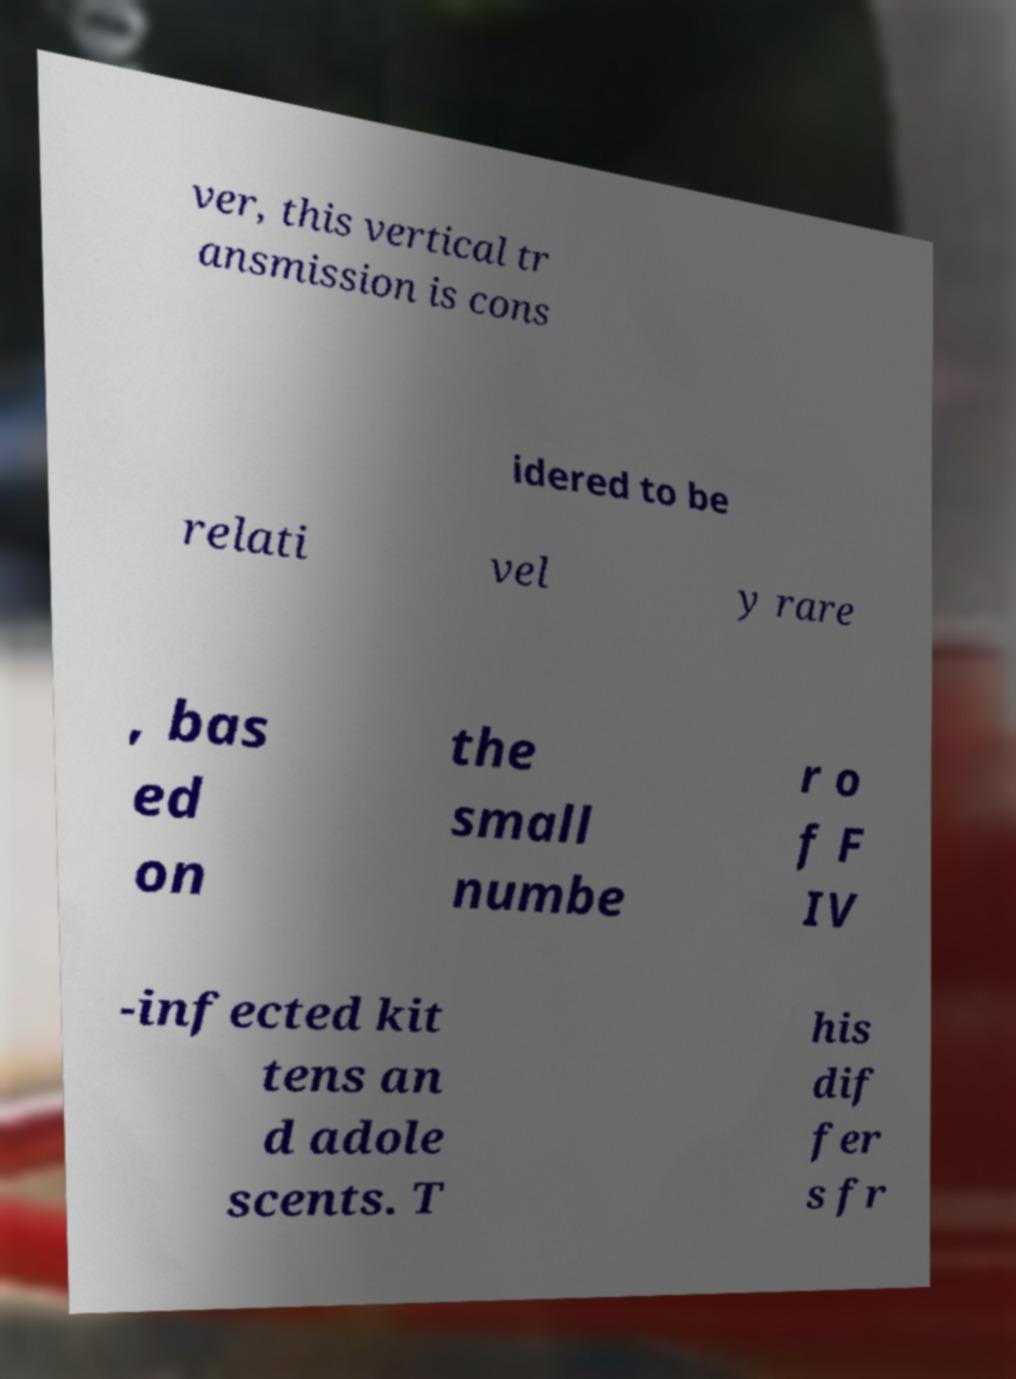I need the written content from this picture converted into text. Can you do that? ver, this vertical tr ansmission is cons idered to be relati vel y rare , bas ed on the small numbe r o f F IV -infected kit tens an d adole scents. T his dif fer s fr 